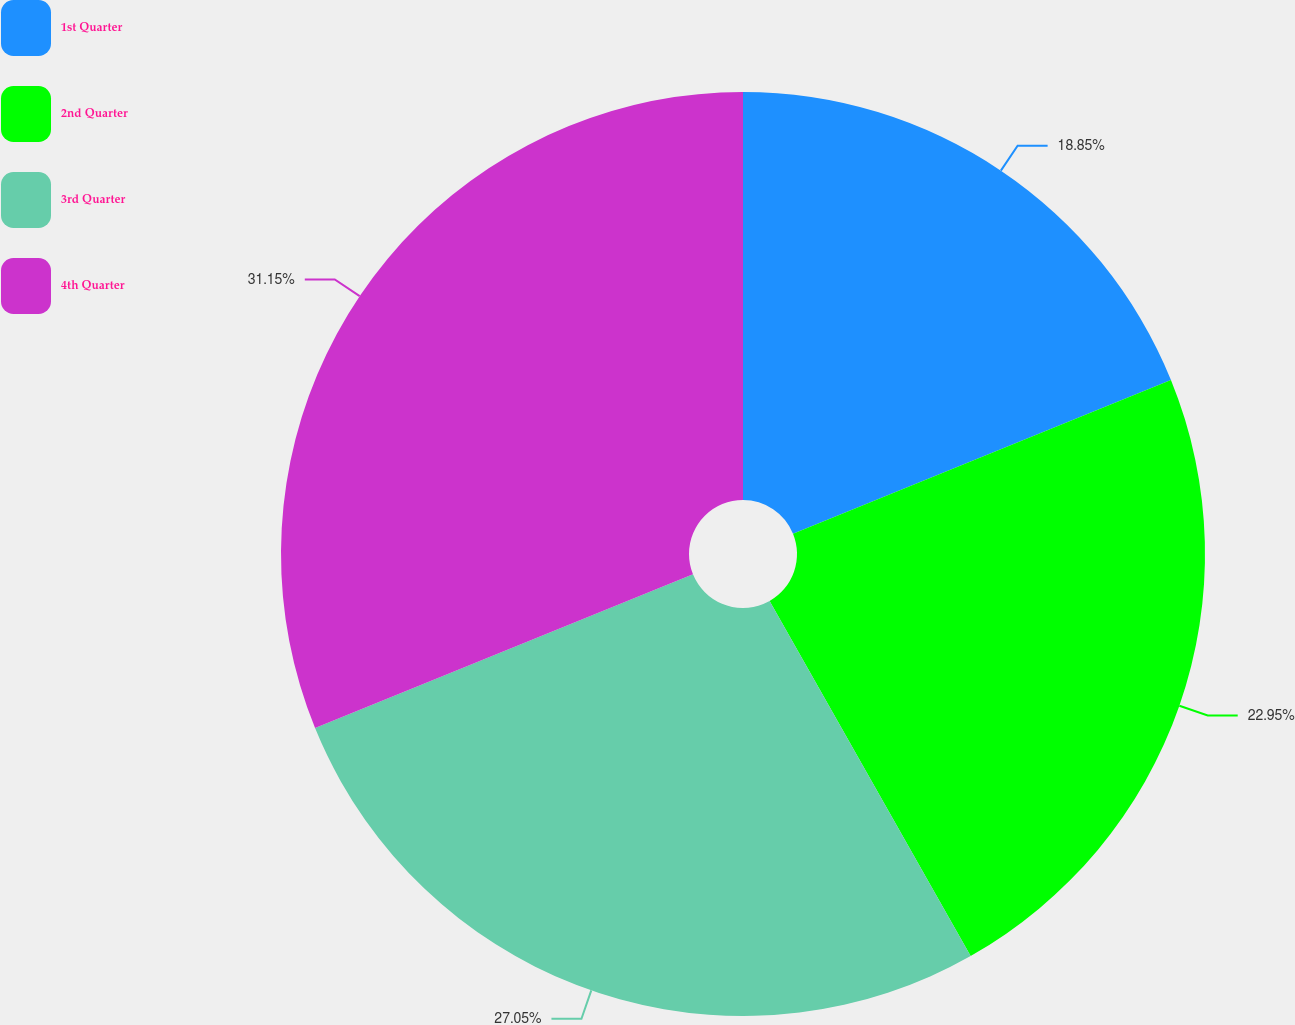Convert chart to OTSL. <chart><loc_0><loc_0><loc_500><loc_500><pie_chart><fcel>1st Quarter<fcel>2nd Quarter<fcel>3rd Quarter<fcel>4th Quarter<nl><fcel>18.85%<fcel>22.95%<fcel>27.05%<fcel>31.15%<nl></chart> 